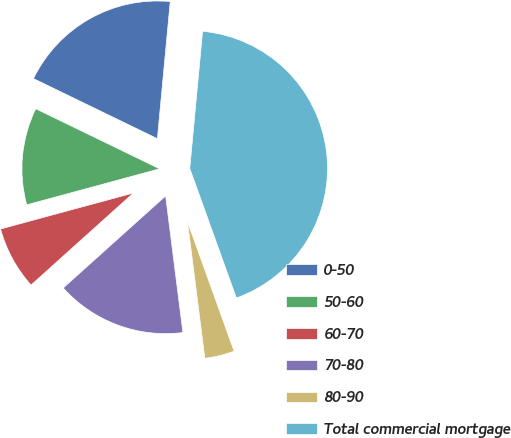Convert chart. <chart><loc_0><loc_0><loc_500><loc_500><pie_chart><fcel>0-50<fcel>50-60<fcel>60-70<fcel>70-80<fcel>80-90<fcel>Total commercial mortgage<nl><fcel>19.3%<fcel>11.4%<fcel>7.44%<fcel>15.35%<fcel>3.49%<fcel>43.02%<nl></chart> 